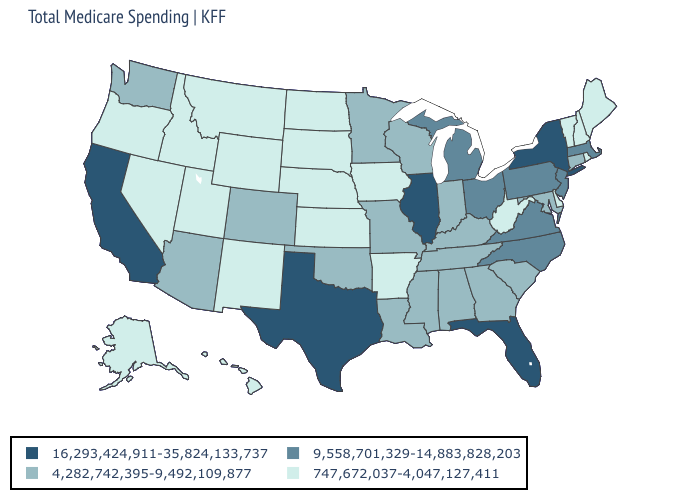Among the states that border Iowa , does Minnesota have the highest value?
Short answer required. No. Name the states that have a value in the range 747,672,037-4,047,127,411?
Give a very brief answer. Alaska, Arkansas, Delaware, Hawaii, Idaho, Iowa, Kansas, Maine, Montana, Nebraska, Nevada, New Hampshire, New Mexico, North Dakota, Oregon, Rhode Island, South Dakota, Utah, Vermont, West Virginia, Wyoming. How many symbols are there in the legend?
Write a very short answer. 4. Name the states that have a value in the range 16,293,424,911-35,824,133,737?
Be succinct. California, Florida, Illinois, New York, Texas. Does Utah have the lowest value in the West?
Answer briefly. Yes. What is the value of Alaska?
Be succinct. 747,672,037-4,047,127,411. Which states have the lowest value in the USA?
Keep it brief. Alaska, Arkansas, Delaware, Hawaii, Idaho, Iowa, Kansas, Maine, Montana, Nebraska, Nevada, New Hampshire, New Mexico, North Dakota, Oregon, Rhode Island, South Dakota, Utah, Vermont, West Virginia, Wyoming. Which states have the lowest value in the South?
Write a very short answer. Arkansas, Delaware, West Virginia. Does Delaware have the same value as Maine?
Write a very short answer. Yes. Among the states that border Massachusetts , does Vermont have the lowest value?
Concise answer only. Yes. Name the states that have a value in the range 16,293,424,911-35,824,133,737?
Keep it brief. California, Florida, Illinois, New York, Texas. Among the states that border Wyoming , which have the highest value?
Give a very brief answer. Colorado. Among the states that border Maryland , which have the lowest value?
Quick response, please. Delaware, West Virginia. Name the states that have a value in the range 4,282,742,395-9,492,109,877?
Be succinct. Alabama, Arizona, Colorado, Connecticut, Georgia, Indiana, Kentucky, Louisiana, Maryland, Minnesota, Mississippi, Missouri, Oklahoma, South Carolina, Tennessee, Washington, Wisconsin. Among the states that border New Jersey , does Pennsylvania have the lowest value?
Be succinct. No. 